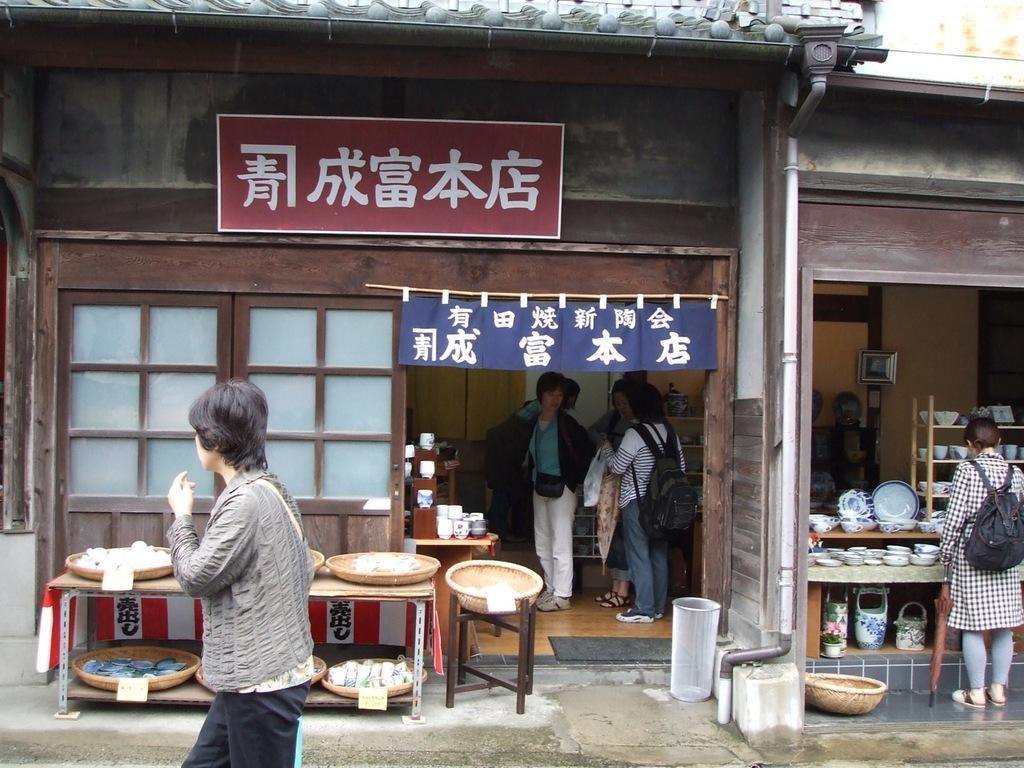In one or two sentences, can you explain what this image depicts? This is a building in which few people are there. On the right a person is looking at cups,plates which are on the table. On the left a person is walking beside him there are some materials on the table. And we can see hoarding on the wall. 